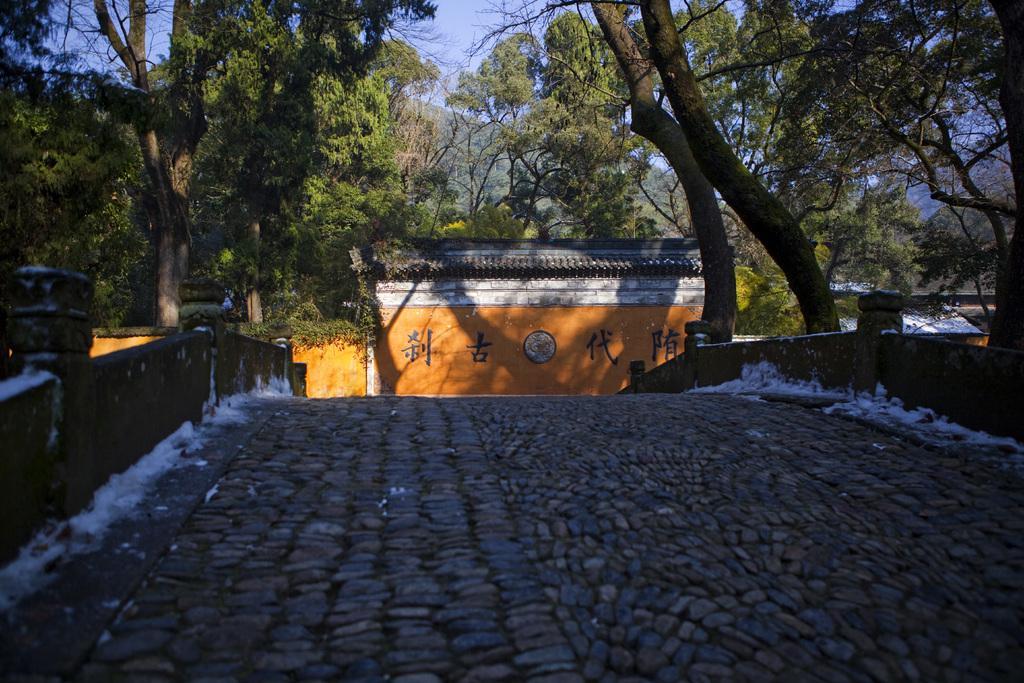Describe this image in one or two sentences. In the front of the image I can see walls and rock surface. In the background of the image there are trees, sky, board and buildings.   